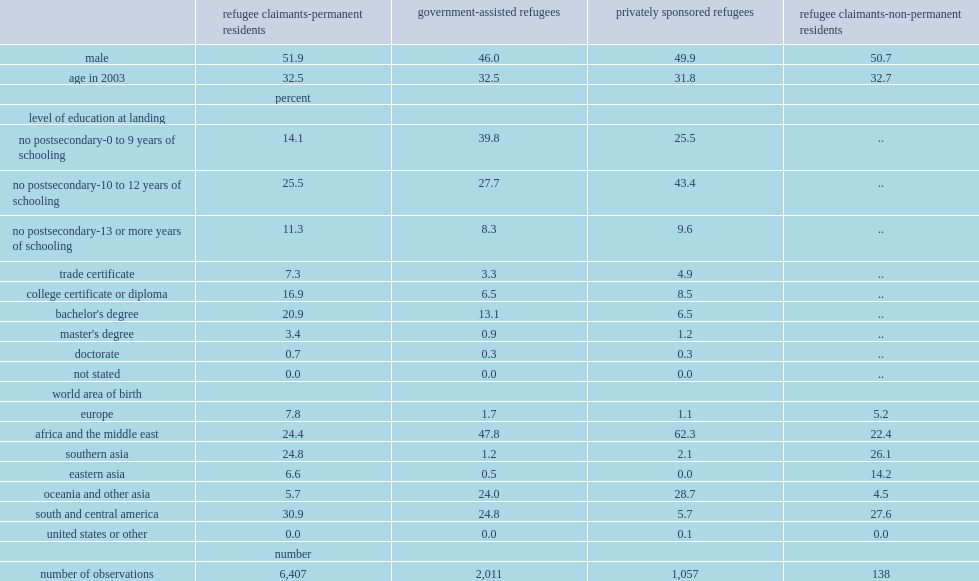I'm looking to parse the entire table for insights. Could you assist me with that? {'header': ['', 'refugee claimants-permanent residents', 'government-assisted refugees', 'privately sponsored refugees', 'refugee claimants-non-permanent residents'], 'rows': [['male', '51.9', '46.0', '49.9', '50.7'], ['age in 2003', '32.5', '32.5', '31.8', '32.7'], ['', 'percent', '', '', ''], ['level of education at landing', '', '', '', ''], ['no postsecondary-0 to 9 years of schooling', '14.1', '39.8', '25.5', '..'], ['no postsecondary-10 to 12 years of schooling', '25.5', '27.7', '43.4', '..'], ['no postsecondary-13 or more years of schooling', '11.3', '8.3', '9.6', '..'], ['trade certificate', '7.3', '3.3', '4.9', '..'], ['college certificate or diploma', '16.9', '6.5', '8.5', '..'], ["bachelor's degree", '20.9', '13.1', '6.5', '..'], ["master's degree", '3.4', '0.9', '1.2', '..'], ['doctorate', '0.7', '0.3', '0.3', '..'], ['not stated', '0.0', '0.0', '0.0', '..'], ['world area of birth', '', '', '', ''], ['europe', '7.8', '1.7', '1.1', '5.2'], ['africa and the middle east', '24.4', '47.8', '62.3', '22.4'], ['southern asia', '24.8', '1.2', '2.1', '26.1'], ['eastern asia', '6.6', '0.5', '0.0', '14.2'], ['oceania and other asia', '5.7', '24.0', '28.7', '4.5'], ['south and central america', '30.9', '24.8', '5.7', '27.6'], ['united states or other', '0.0', '0.0', '0.1', '0.0'], ['', 'number', '', '', ''], ['number of observations', '6,407', '2,011', '1,057', '138']]} What is the percentage of rc-prs held a postsecondary qualification at landing? 49.2. What is the percentage of gars held a postsecondary qualification at landing? 24.1. What is the percentage of psrs held a postsecondary qualification at landing? 21.4. What is the percentage of rc-prs held a bachelor's degree or higher? 25. What is the percentage of gars held a bachelor's degree or higher? 14.3. What is the percentage of psrs held a bachelor's degree or higher? 8. Which place rc-prs were more likely to have been born in? South and central america. What is the average age of psrs at landing for resettled refugees or upon making a refugee claim? 31.8. What is the average age of rc-prs at landing for resettled refugees or upon making a refugee claim? 32.5. What is the average age of gars at landing for resettled refugees or upon making a refugee claim? 32.5. 